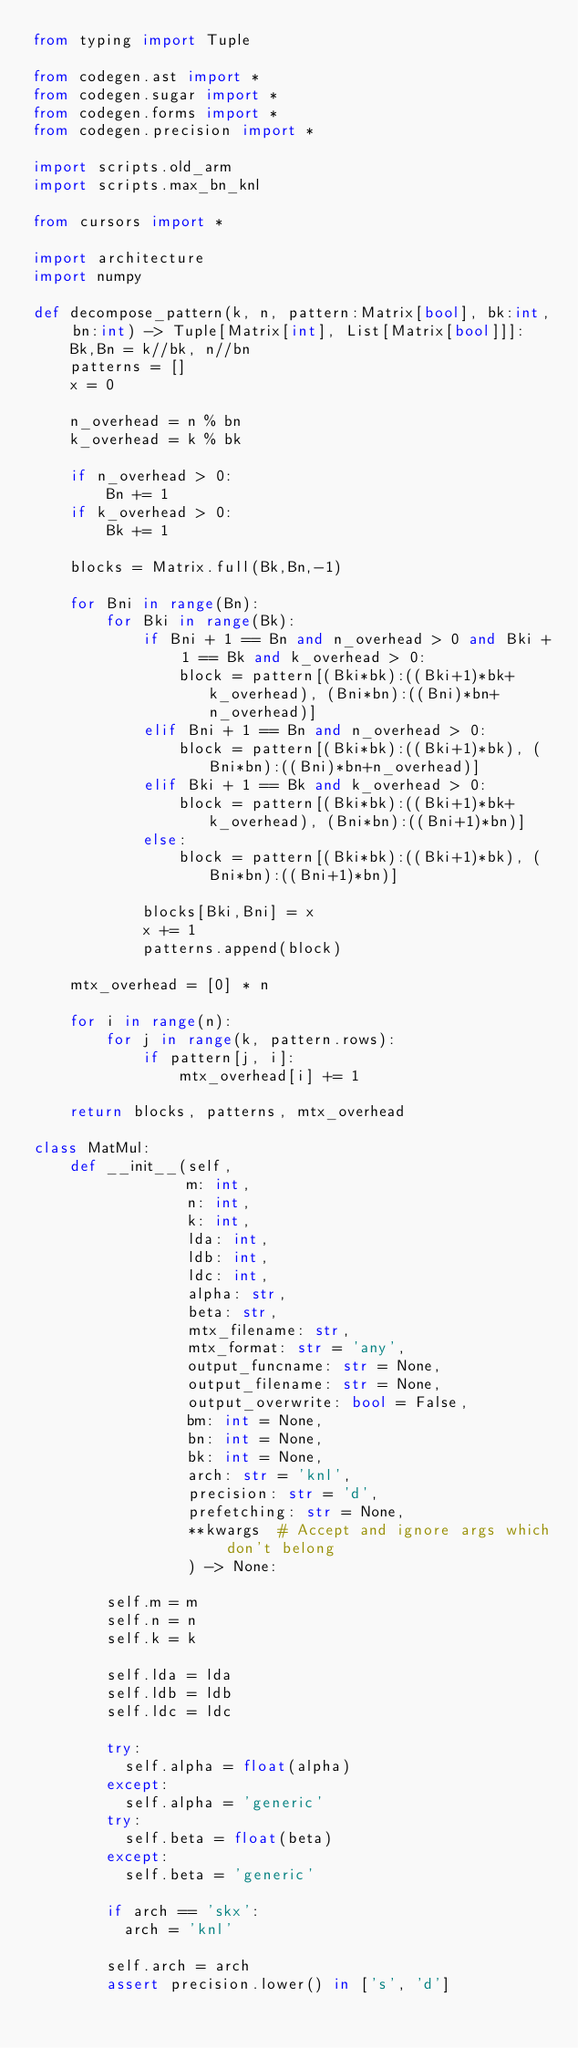<code> <loc_0><loc_0><loc_500><loc_500><_Python_>from typing import Tuple

from codegen.ast import *
from codegen.sugar import *
from codegen.forms import *
from codegen.precision import *

import scripts.old_arm
import scripts.max_bn_knl

from cursors import *

import architecture
import numpy

def decompose_pattern(k, n, pattern:Matrix[bool], bk:int, bn:int) -> Tuple[Matrix[int], List[Matrix[bool]]]:
    Bk,Bn = k//bk, n//bn
    patterns = []
    x = 0

    n_overhead = n % bn
    k_overhead = k % bk

    if n_overhead > 0:
        Bn += 1
    if k_overhead > 0:
        Bk += 1

    blocks = Matrix.full(Bk,Bn,-1)

    for Bni in range(Bn):
        for Bki in range(Bk):
            if Bni + 1 == Bn and n_overhead > 0 and Bki + 1 == Bk and k_overhead > 0:
                block = pattern[(Bki*bk):((Bki+1)*bk+k_overhead), (Bni*bn):((Bni)*bn+n_overhead)]
            elif Bni + 1 == Bn and n_overhead > 0:
                block = pattern[(Bki*bk):((Bki+1)*bk), (Bni*bn):((Bni)*bn+n_overhead)]
            elif Bki + 1 == Bk and k_overhead > 0:
                block = pattern[(Bki*bk):((Bki+1)*bk+k_overhead), (Bni*bn):((Bni+1)*bn)]
            else:
                block = pattern[(Bki*bk):((Bki+1)*bk), (Bni*bn):((Bni+1)*bn)]
            
            blocks[Bki,Bni] = x
            x += 1
            patterns.append(block)

    mtx_overhead = [0] * n

    for i in range(n):
        for j in range(k, pattern.rows):
            if pattern[j, i]:
                mtx_overhead[i] += 1

    return blocks, patterns, mtx_overhead

class MatMul:
    def __init__(self,
                 m: int, 
                 n: int, 
                 k: int, 
                 lda: int, 
                 ldb: int, 
                 ldc: int,
                 alpha: str,
                 beta: str,
                 mtx_filename: str,
                 mtx_format: str = 'any',
                 output_funcname: str = None,
                 output_filename: str = None,
                 output_overwrite: bool = False,
                 bm: int = None, 
                 bn: int = None, 
                 bk: int = None,
                 arch: str = 'knl',
                 precision: str = 'd',
                 prefetching: str = None,
                 **kwargs  # Accept and ignore args which don't belong
                 ) -> None:

        self.m = m
        self.n = n
        self.k = k

        self.lda = lda
        self.ldb = ldb
        self.ldc = ldc

        try:
          self.alpha = float(alpha)
        except:
          self.alpha = 'generic'
        try:
          self.beta = float(beta)
        except:
          self.beta = 'generic'

        if arch == 'skx':
          arch = 'knl'

        self.arch = arch
        assert precision.lower() in ['s', 'd']</code> 